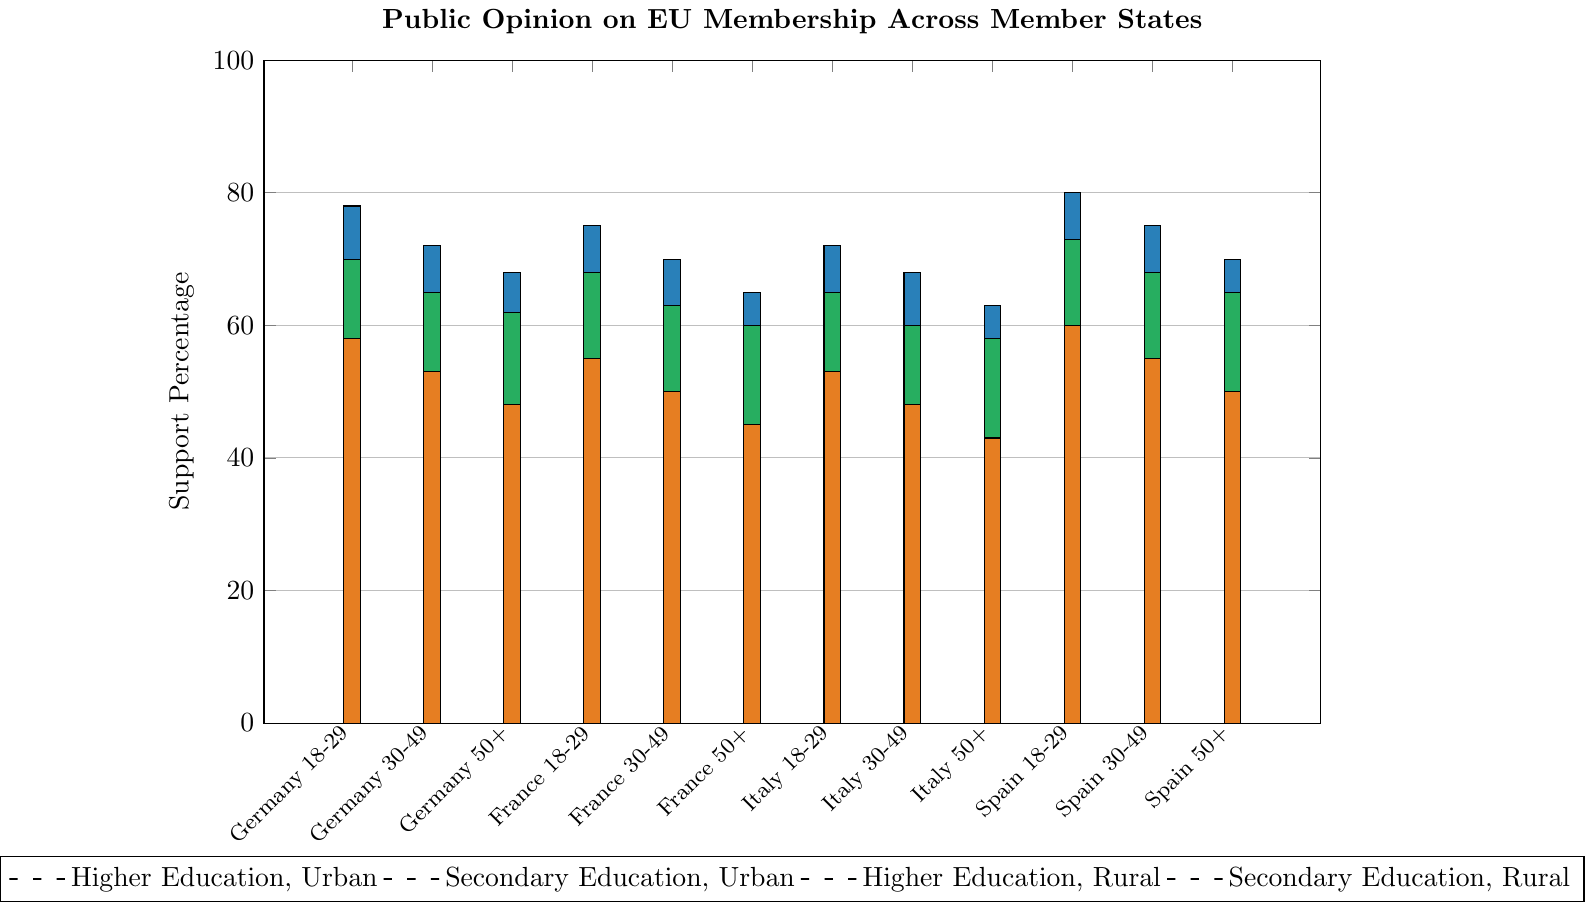What is the highest support percentage for EU membership among all age and education groups in Spain? The highest support percentage in Spain occurs for individuals aged 18-29 with higher education, urban residents.
Answer: 80 How does the support percentage for EU membership among Germany's 50+ age group with higher education in urban areas compare to the same demographic group in rural areas? The support percentage for the 50+ age group with higher education in urban areas is 68%, while in rural areas it is 62%. Comparing these, urban areas have a higher support percentage by 6%.
Answer: Urban areas have 6% higher support Which country and age group with secondary education in urban areas shows the lowest support for EU membership? Among countries and age groups with secondary education in urban areas, the lowest support percentage for EU membership is for Italy's 50+ age group (50%).
Answer: Italy 50+ How much greater is the support percentage for EU membership among France's 18-29 age group with higher education in urban areas compared to Germany's 30-49 age group with secondary education in rural areas? The support percentage for France's 18-29 age group with higher education in urban areas is 75%, while for Germany's 30-49 age group with secondary education in rural areas it is 53%. The difference is 75% - 53% = 22%.
Answer: 22% Which countries show higher support for EU membership in rural areas compared to urban areas for the 30-49 age group with higher education? For the 30-49 age group with higher education, both Germany (65% rural vs 60% urban), France (63% rural vs 58% urban), and Italy (60% rural vs 55% urban) show higher support for EU membership in rural areas compared to urban areas. Spain shows equal support (68% urban and rural).
Answer: Germany, France, and Italy Compare the support for EU membership between rural and urban areas for the 50+ age group with secondary education in Spain. Is the support higher in rural areas? The support percentage for the 50+ age group with secondary education in urban areas of Spain is 50%, while it is 50% in rural areas. The support is equal in urban and rural areas.
Answer: Support is equal What is the average support percentage for EU membership among all age groups in Italy with secondary education in rural areas? The support percentages for Italy's 18-29, 30-49, and 50+ age groups with secondary education in rural areas are 53%, 48%, and 43%. The average is calculated as (53 + 48 + 43) / 3 = 48%.
Answer: 48% Which group has the highest discrepancy in support for EU membership between urban and rural areas within the same age and education category? Looking at the discrepancies, the highest difference is for the 30-49 age group with secondary education in Germany (60% urban vs 53% rural), a difference of 7%.
Answer: Germany 30-49, Secondary Education How does support for EU membership in urban areas for the 18-29 age group with secondary education compare between France and Italy? The support percentage for the 18-29 age group with secondary education in urban areas is 62% in France and 60% in Italy. France shows higher support by 2%.
Answer: France by 2% 